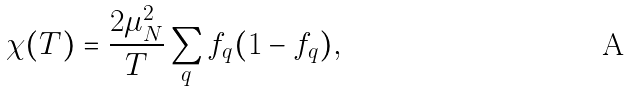Convert formula to latex. <formula><loc_0><loc_0><loc_500><loc_500>\chi ( T ) = \frac { 2 \mu _ { N } ^ { 2 } } { T } \sum _ { q } f _ { q } ( 1 - f _ { q } ) ,</formula> 